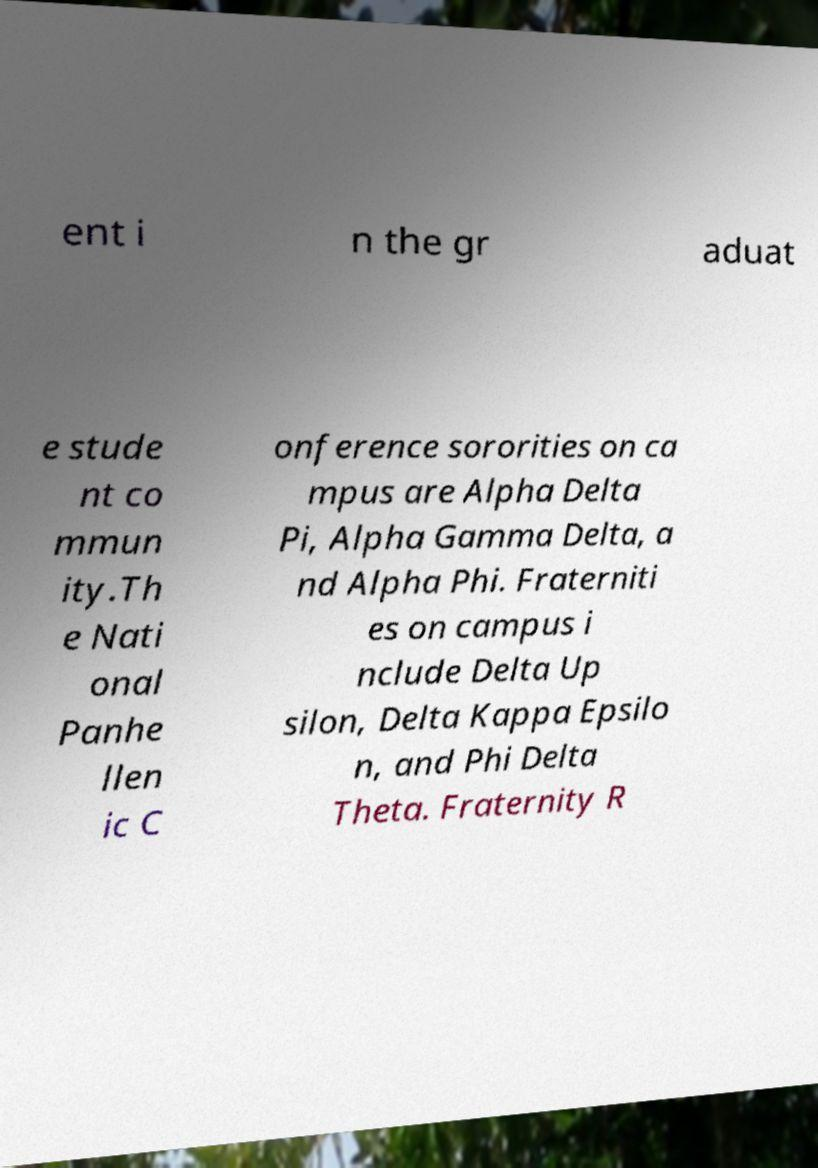Please read and relay the text visible in this image. What does it say? ent i n the gr aduat e stude nt co mmun ity.Th e Nati onal Panhe llen ic C onference sororities on ca mpus are Alpha Delta Pi, Alpha Gamma Delta, a nd Alpha Phi. Fraterniti es on campus i nclude Delta Up silon, Delta Kappa Epsilo n, and Phi Delta Theta. Fraternity R 